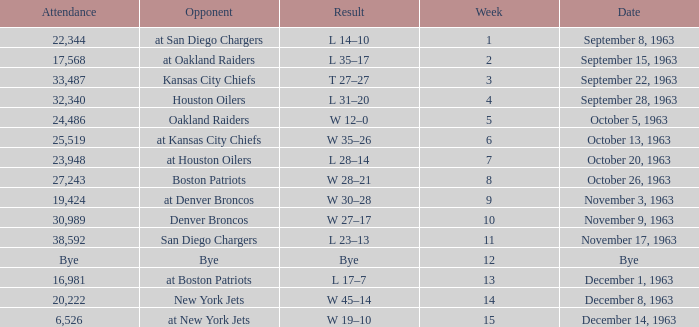Which rival has a score of w 19-10? At new york jets. 